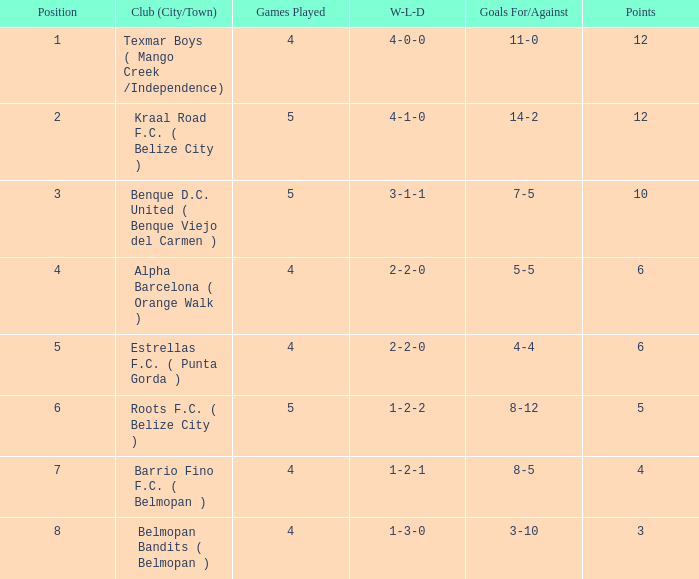What's the goals for/against with w-l-d being 3-1-1 7-5. 